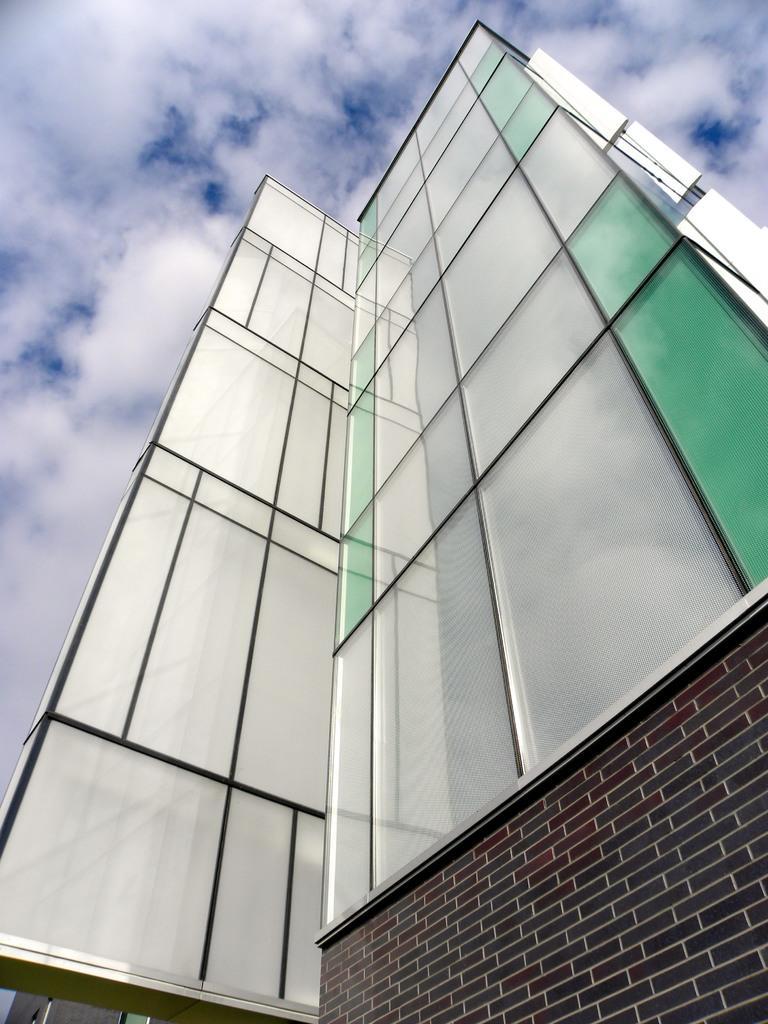In one or two sentences, can you explain what this image depicts? In this image there is a building. In the background there is sky. 